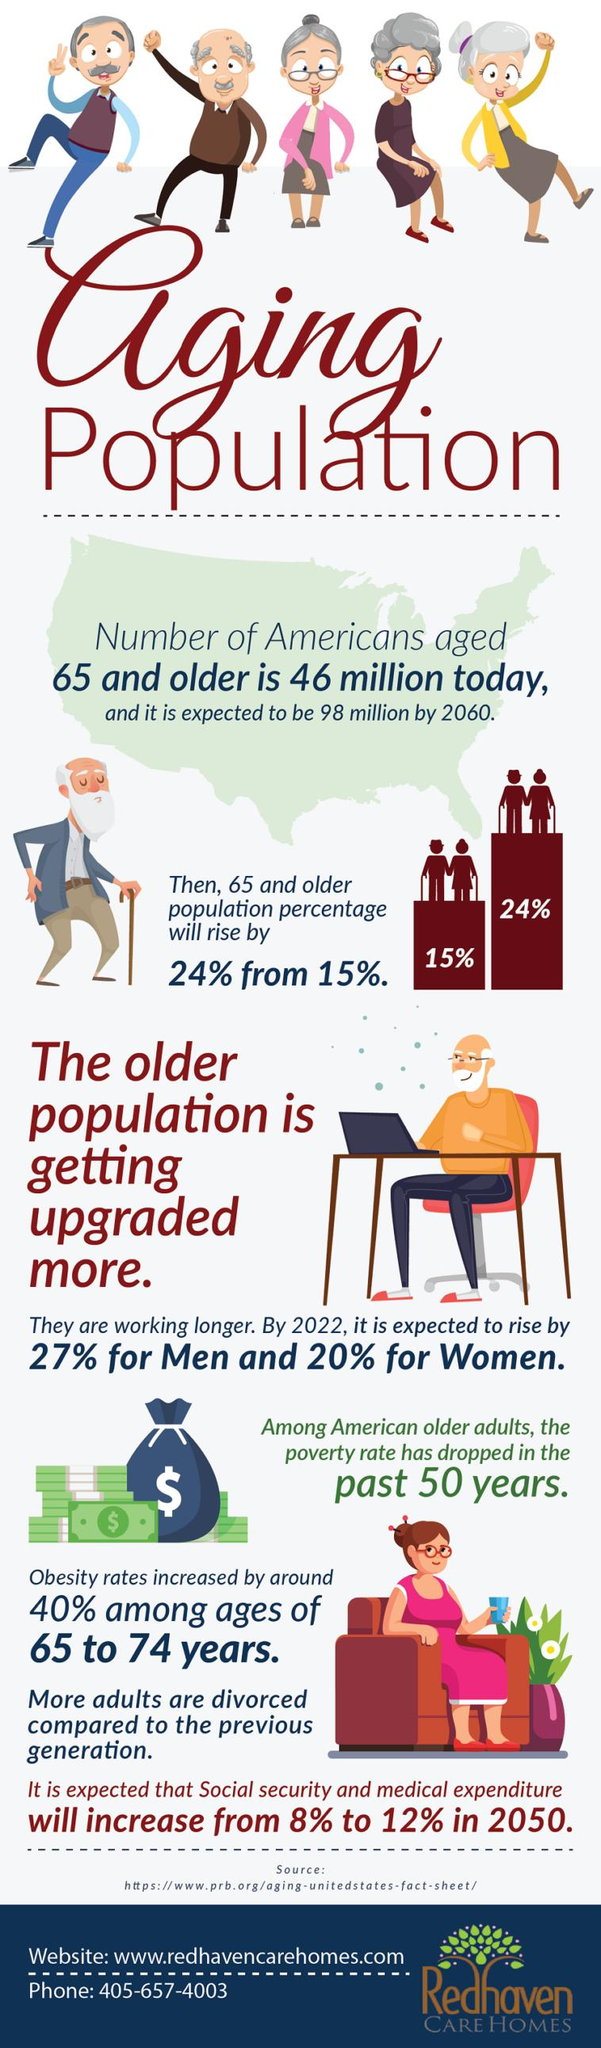Identify some key points in this picture. In 2050, social security and medical expenditure is projected to experience a 4% increase. The population of individuals aged 65 and older increased by 9% in . 